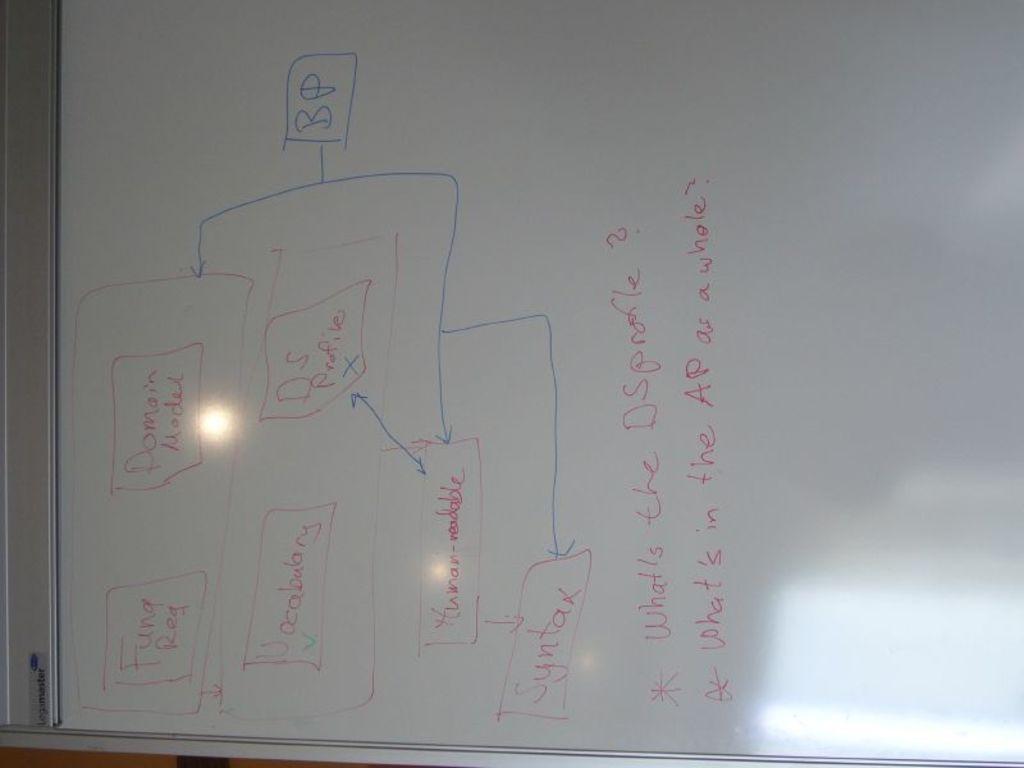What two letters are written in blue on the whiteboard?
Give a very brief answer. Bp. 